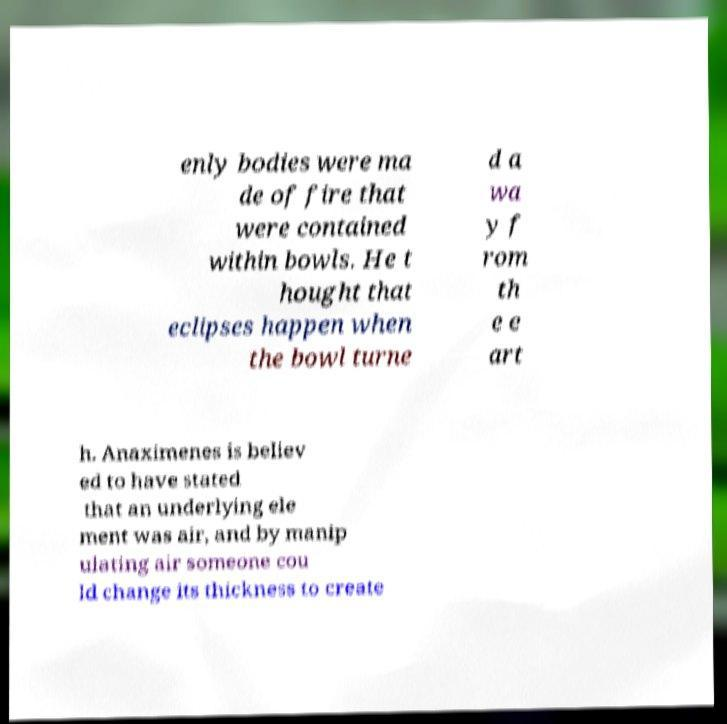Please read and relay the text visible in this image. What does it say? enly bodies were ma de of fire that were contained within bowls. He t hought that eclipses happen when the bowl turne d a wa y f rom th e e art h. Anaximenes is believ ed to have stated that an underlying ele ment was air, and by manip ulating air someone cou ld change its thickness to create 